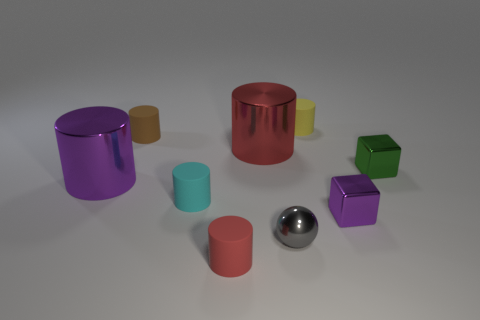Subtract all small brown rubber cylinders. How many cylinders are left? 5 Subtract all gray balls. How many red cylinders are left? 2 Subtract all yellow cylinders. How many cylinders are left? 5 Add 1 gray rubber cubes. How many objects exist? 10 Subtract all gray cylinders. Subtract all yellow balls. How many cylinders are left? 6 Subtract all cylinders. How many objects are left? 3 Subtract all purple cylinders. Subtract all spheres. How many objects are left? 7 Add 3 large red cylinders. How many large red cylinders are left? 4 Add 1 small metal things. How many small metal things exist? 4 Subtract 0 blue cylinders. How many objects are left? 9 